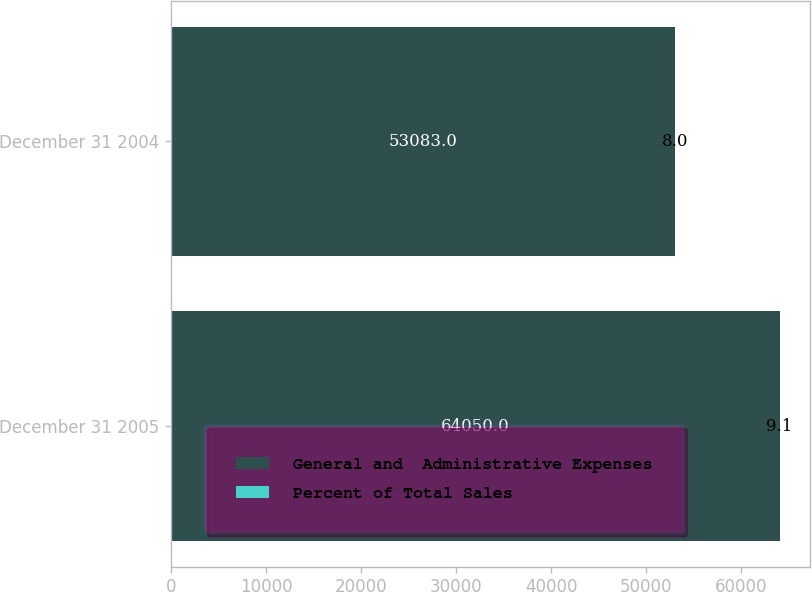<chart> <loc_0><loc_0><loc_500><loc_500><stacked_bar_chart><ecel><fcel>December 31 2005<fcel>December 31 2004<nl><fcel>General and  Administrative Expenses<fcel>64050<fcel>53083<nl><fcel>Percent of Total Sales<fcel>9.1<fcel>8<nl></chart> 